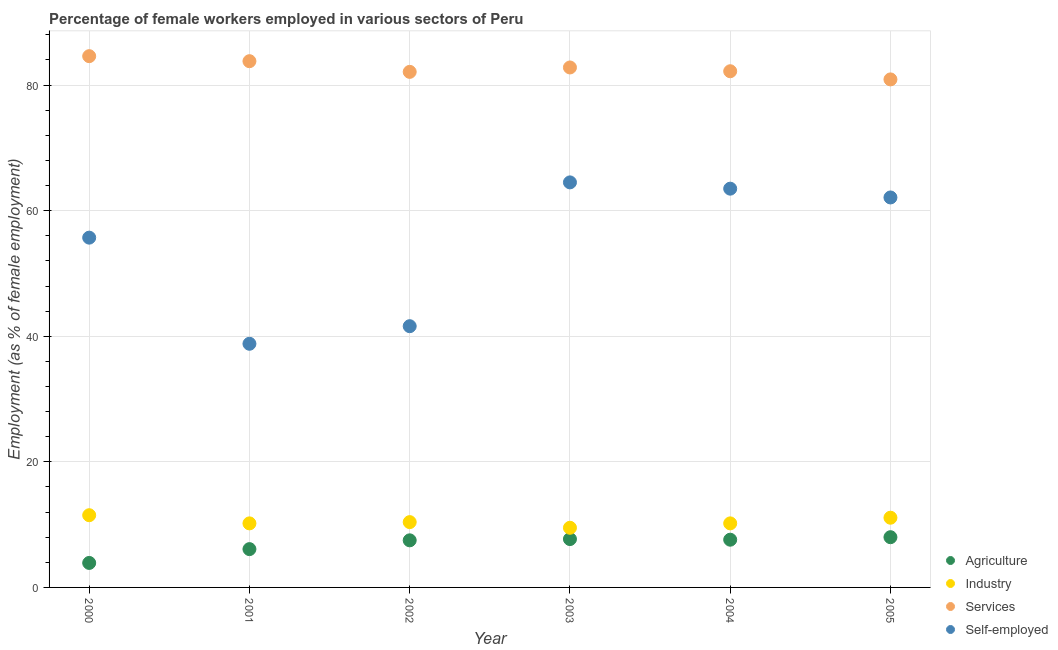What is the percentage of female workers in industry in 2004?
Offer a terse response. 10.2. In which year was the percentage of self employed female workers maximum?
Offer a terse response. 2003. In which year was the percentage of female workers in industry minimum?
Make the answer very short. 2003. What is the total percentage of self employed female workers in the graph?
Provide a succinct answer. 326.2. What is the difference between the percentage of female workers in services in 2003 and that in 2004?
Offer a very short reply. 0.6. What is the difference between the percentage of self employed female workers in 2001 and the percentage of female workers in services in 2004?
Ensure brevity in your answer.  -43.4. What is the average percentage of female workers in agriculture per year?
Ensure brevity in your answer.  6.8. In the year 2004, what is the difference between the percentage of female workers in industry and percentage of female workers in agriculture?
Make the answer very short. 2.6. In how many years, is the percentage of female workers in industry greater than 64 %?
Offer a terse response. 0. What is the ratio of the percentage of female workers in agriculture in 2001 to that in 2004?
Your answer should be compact. 0.8. Is the percentage of female workers in agriculture in 2001 less than that in 2005?
Make the answer very short. Yes. Is the difference between the percentage of female workers in services in 2003 and 2004 greater than the difference between the percentage of self employed female workers in 2003 and 2004?
Make the answer very short. No. What is the difference between the highest and the second highest percentage of female workers in industry?
Your answer should be compact. 0.4. What is the difference between the highest and the lowest percentage of female workers in industry?
Make the answer very short. 2. In how many years, is the percentage of female workers in industry greater than the average percentage of female workers in industry taken over all years?
Keep it short and to the point. 2. Is it the case that in every year, the sum of the percentage of female workers in services and percentage of self employed female workers is greater than the sum of percentage of female workers in agriculture and percentage of female workers in industry?
Ensure brevity in your answer.  No. Is it the case that in every year, the sum of the percentage of female workers in agriculture and percentage of female workers in industry is greater than the percentage of female workers in services?
Provide a short and direct response. No. Does the percentage of female workers in services monotonically increase over the years?
Your answer should be very brief. No. What is the difference between two consecutive major ticks on the Y-axis?
Offer a terse response. 20. Does the graph contain any zero values?
Provide a short and direct response. No. Does the graph contain grids?
Your answer should be very brief. Yes. How many legend labels are there?
Your answer should be compact. 4. How are the legend labels stacked?
Provide a short and direct response. Vertical. What is the title of the graph?
Ensure brevity in your answer.  Percentage of female workers employed in various sectors of Peru. Does "Portugal" appear as one of the legend labels in the graph?
Provide a short and direct response. No. What is the label or title of the X-axis?
Offer a terse response. Year. What is the label or title of the Y-axis?
Your answer should be very brief. Employment (as % of female employment). What is the Employment (as % of female employment) of Agriculture in 2000?
Your response must be concise. 3.9. What is the Employment (as % of female employment) in Services in 2000?
Give a very brief answer. 84.6. What is the Employment (as % of female employment) in Self-employed in 2000?
Give a very brief answer. 55.7. What is the Employment (as % of female employment) of Agriculture in 2001?
Give a very brief answer. 6.1. What is the Employment (as % of female employment) of Industry in 2001?
Your response must be concise. 10.2. What is the Employment (as % of female employment) of Services in 2001?
Your response must be concise. 83.8. What is the Employment (as % of female employment) of Self-employed in 2001?
Offer a terse response. 38.8. What is the Employment (as % of female employment) of Agriculture in 2002?
Keep it short and to the point. 7.5. What is the Employment (as % of female employment) in Industry in 2002?
Your answer should be compact. 10.4. What is the Employment (as % of female employment) in Services in 2002?
Make the answer very short. 82.1. What is the Employment (as % of female employment) of Self-employed in 2002?
Provide a succinct answer. 41.6. What is the Employment (as % of female employment) of Agriculture in 2003?
Keep it short and to the point. 7.7. What is the Employment (as % of female employment) in Services in 2003?
Give a very brief answer. 82.8. What is the Employment (as % of female employment) of Self-employed in 2003?
Make the answer very short. 64.5. What is the Employment (as % of female employment) in Agriculture in 2004?
Give a very brief answer. 7.6. What is the Employment (as % of female employment) in Industry in 2004?
Provide a short and direct response. 10.2. What is the Employment (as % of female employment) of Services in 2004?
Keep it short and to the point. 82.2. What is the Employment (as % of female employment) of Self-employed in 2004?
Ensure brevity in your answer.  63.5. What is the Employment (as % of female employment) of Agriculture in 2005?
Offer a very short reply. 8. What is the Employment (as % of female employment) in Industry in 2005?
Ensure brevity in your answer.  11.1. What is the Employment (as % of female employment) in Services in 2005?
Keep it short and to the point. 80.9. What is the Employment (as % of female employment) of Self-employed in 2005?
Provide a short and direct response. 62.1. Across all years, what is the maximum Employment (as % of female employment) in Agriculture?
Provide a succinct answer. 8. Across all years, what is the maximum Employment (as % of female employment) of Services?
Give a very brief answer. 84.6. Across all years, what is the maximum Employment (as % of female employment) of Self-employed?
Make the answer very short. 64.5. Across all years, what is the minimum Employment (as % of female employment) of Agriculture?
Offer a very short reply. 3.9. Across all years, what is the minimum Employment (as % of female employment) of Services?
Keep it short and to the point. 80.9. Across all years, what is the minimum Employment (as % of female employment) of Self-employed?
Keep it short and to the point. 38.8. What is the total Employment (as % of female employment) of Agriculture in the graph?
Give a very brief answer. 40.8. What is the total Employment (as % of female employment) of Industry in the graph?
Offer a very short reply. 62.9. What is the total Employment (as % of female employment) of Services in the graph?
Provide a short and direct response. 496.4. What is the total Employment (as % of female employment) in Self-employed in the graph?
Offer a very short reply. 326.2. What is the difference between the Employment (as % of female employment) in Agriculture in 2000 and that in 2001?
Your response must be concise. -2.2. What is the difference between the Employment (as % of female employment) in Industry in 2000 and that in 2001?
Keep it short and to the point. 1.3. What is the difference between the Employment (as % of female employment) of Services in 2000 and that in 2001?
Keep it short and to the point. 0.8. What is the difference between the Employment (as % of female employment) in Industry in 2000 and that in 2002?
Make the answer very short. 1.1. What is the difference between the Employment (as % of female employment) of Self-employed in 2000 and that in 2003?
Make the answer very short. -8.8. What is the difference between the Employment (as % of female employment) of Industry in 2000 and that in 2004?
Give a very brief answer. 1.3. What is the difference between the Employment (as % of female employment) in Agriculture in 2000 and that in 2005?
Make the answer very short. -4.1. What is the difference between the Employment (as % of female employment) of Industry in 2000 and that in 2005?
Make the answer very short. 0.4. What is the difference between the Employment (as % of female employment) of Services in 2000 and that in 2005?
Your response must be concise. 3.7. What is the difference between the Employment (as % of female employment) of Self-employed in 2000 and that in 2005?
Offer a terse response. -6.4. What is the difference between the Employment (as % of female employment) in Agriculture in 2001 and that in 2002?
Make the answer very short. -1.4. What is the difference between the Employment (as % of female employment) of Self-employed in 2001 and that in 2003?
Provide a short and direct response. -25.7. What is the difference between the Employment (as % of female employment) in Industry in 2001 and that in 2004?
Make the answer very short. 0. What is the difference between the Employment (as % of female employment) of Self-employed in 2001 and that in 2004?
Offer a terse response. -24.7. What is the difference between the Employment (as % of female employment) of Self-employed in 2001 and that in 2005?
Give a very brief answer. -23.3. What is the difference between the Employment (as % of female employment) of Industry in 2002 and that in 2003?
Offer a very short reply. 0.9. What is the difference between the Employment (as % of female employment) in Services in 2002 and that in 2003?
Ensure brevity in your answer.  -0.7. What is the difference between the Employment (as % of female employment) of Self-employed in 2002 and that in 2003?
Your answer should be very brief. -22.9. What is the difference between the Employment (as % of female employment) in Agriculture in 2002 and that in 2004?
Your response must be concise. -0.1. What is the difference between the Employment (as % of female employment) of Services in 2002 and that in 2004?
Provide a succinct answer. -0.1. What is the difference between the Employment (as % of female employment) in Self-employed in 2002 and that in 2004?
Offer a very short reply. -21.9. What is the difference between the Employment (as % of female employment) in Self-employed in 2002 and that in 2005?
Make the answer very short. -20.5. What is the difference between the Employment (as % of female employment) of Industry in 2003 and that in 2004?
Keep it short and to the point. -0.7. What is the difference between the Employment (as % of female employment) in Services in 2003 and that in 2004?
Provide a short and direct response. 0.6. What is the difference between the Employment (as % of female employment) in Agriculture in 2003 and that in 2005?
Your response must be concise. -0.3. What is the difference between the Employment (as % of female employment) in Industry in 2003 and that in 2005?
Offer a very short reply. -1.6. What is the difference between the Employment (as % of female employment) in Self-employed in 2003 and that in 2005?
Keep it short and to the point. 2.4. What is the difference between the Employment (as % of female employment) in Industry in 2004 and that in 2005?
Make the answer very short. -0.9. What is the difference between the Employment (as % of female employment) in Services in 2004 and that in 2005?
Provide a short and direct response. 1.3. What is the difference between the Employment (as % of female employment) in Self-employed in 2004 and that in 2005?
Provide a succinct answer. 1.4. What is the difference between the Employment (as % of female employment) in Agriculture in 2000 and the Employment (as % of female employment) in Industry in 2001?
Keep it short and to the point. -6.3. What is the difference between the Employment (as % of female employment) in Agriculture in 2000 and the Employment (as % of female employment) in Services in 2001?
Offer a terse response. -79.9. What is the difference between the Employment (as % of female employment) of Agriculture in 2000 and the Employment (as % of female employment) of Self-employed in 2001?
Your response must be concise. -34.9. What is the difference between the Employment (as % of female employment) of Industry in 2000 and the Employment (as % of female employment) of Services in 2001?
Your answer should be compact. -72.3. What is the difference between the Employment (as % of female employment) of Industry in 2000 and the Employment (as % of female employment) of Self-employed in 2001?
Provide a short and direct response. -27.3. What is the difference between the Employment (as % of female employment) of Services in 2000 and the Employment (as % of female employment) of Self-employed in 2001?
Make the answer very short. 45.8. What is the difference between the Employment (as % of female employment) of Agriculture in 2000 and the Employment (as % of female employment) of Services in 2002?
Give a very brief answer. -78.2. What is the difference between the Employment (as % of female employment) of Agriculture in 2000 and the Employment (as % of female employment) of Self-employed in 2002?
Your response must be concise. -37.7. What is the difference between the Employment (as % of female employment) of Industry in 2000 and the Employment (as % of female employment) of Services in 2002?
Your answer should be very brief. -70.6. What is the difference between the Employment (as % of female employment) of Industry in 2000 and the Employment (as % of female employment) of Self-employed in 2002?
Your answer should be very brief. -30.1. What is the difference between the Employment (as % of female employment) in Services in 2000 and the Employment (as % of female employment) in Self-employed in 2002?
Offer a very short reply. 43. What is the difference between the Employment (as % of female employment) of Agriculture in 2000 and the Employment (as % of female employment) of Industry in 2003?
Offer a terse response. -5.6. What is the difference between the Employment (as % of female employment) of Agriculture in 2000 and the Employment (as % of female employment) of Services in 2003?
Your answer should be very brief. -78.9. What is the difference between the Employment (as % of female employment) in Agriculture in 2000 and the Employment (as % of female employment) in Self-employed in 2003?
Provide a succinct answer. -60.6. What is the difference between the Employment (as % of female employment) in Industry in 2000 and the Employment (as % of female employment) in Services in 2003?
Make the answer very short. -71.3. What is the difference between the Employment (as % of female employment) of Industry in 2000 and the Employment (as % of female employment) of Self-employed in 2003?
Your answer should be very brief. -53. What is the difference between the Employment (as % of female employment) of Services in 2000 and the Employment (as % of female employment) of Self-employed in 2003?
Provide a succinct answer. 20.1. What is the difference between the Employment (as % of female employment) in Agriculture in 2000 and the Employment (as % of female employment) in Industry in 2004?
Keep it short and to the point. -6.3. What is the difference between the Employment (as % of female employment) of Agriculture in 2000 and the Employment (as % of female employment) of Services in 2004?
Give a very brief answer. -78.3. What is the difference between the Employment (as % of female employment) in Agriculture in 2000 and the Employment (as % of female employment) in Self-employed in 2004?
Offer a terse response. -59.6. What is the difference between the Employment (as % of female employment) in Industry in 2000 and the Employment (as % of female employment) in Services in 2004?
Your response must be concise. -70.7. What is the difference between the Employment (as % of female employment) of Industry in 2000 and the Employment (as % of female employment) of Self-employed in 2004?
Your answer should be very brief. -52. What is the difference between the Employment (as % of female employment) in Services in 2000 and the Employment (as % of female employment) in Self-employed in 2004?
Offer a terse response. 21.1. What is the difference between the Employment (as % of female employment) of Agriculture in 2000 and the Employment (as % of female employment) of Industry in 2005?
Ensure brevity in your answer.  -7.2. What is the difference between the Employment (as % of female employment) of Agriculture in 2000 and the Employment (as % of female employment) of Services in 2005?
Make the answer very short. -77. What is the difference between the Employment (as % of female employment) in Agriculture in 2000 and the Employment (as % of female employment) in Self-employed in 2005?
Give a very brief answer. -58.2. What is the difference between the Employment (as % of female employment) in Industry in 2000 and the Employment (as % of female employment) in Services in 2005?
Your answer should be very brief. -69.4. What is the difference between the Employment (as % of female employment) in Industry in 2000 and the Employment (as % of female employment) in Self-employed in 2005?
Provide a short and direct response. -50.6. What is the difference between the Employment (as % of female employment) in Agriculture in 2001 and the Employment (as % of female employment) in Services in 2002?
Offer a very short reply. -76. What is the difference between the Employment (as % of female employment) in Agriculture in 2001 and the Employment (as % of female employment) in Self-employed in 2002?
Keep it short and to the point. -35.5. What is the difference between the Employment (as % of female employment) of Industry in 2001 and the Employment (as % of female employment) of Services in 2002?
Provide a short and direct response. -71.9. What is the difference between the Employment (as % of female employment) of Industry in 2001 and the Employment (as % of female employment) of Self-employed in 2002?
Your answer should be very brief. -31.4. What is the difference between the Employment (as % of female employment) of Services in 2001 and the Employment (as % of female employment) of Self-employed in 2002?
Provide a short and direct response. 42.2. What is the difference between the Employment (as % of female employment) of Agriculture in 2001 and the Employment (as % of female employment) of Industry in 2003?
Keep it short and to the point. -3.4. What is the difference between the Employment (as % of female employment) in Agriculture in 2001 and the Employment (as % of female employment) in Services in 2003?
Your answer should be compact. -76.7. What is the difference between the Employment (as % of female employment) of Agriculture in 2001 and the Employment (as % of female employment) of Self-employed in 2003?
Provide a short and direct response. -58.4. What is the difference between the Employment (as % of female employment) of Industry in 2001 and the Employment (as % of female employment) of Services in 2003?
Provide a succinct answer. -72.6. What is the difference between the Employment (as % of female employment) in Industry in 2001 and the Employment (as % of female employment) in Self-employed in 2003?
Your answer should be very brief. -54.3. What is the difference between the Employment (as % of female employment) of Services in 2001 and the Employment (as % of female employment) of Self-employed in 2003?
Provide a succinct answer. 19.3. What is the difference between the Employment (as % of female employment) of Agriculture in 2001 and the Employment (as % of female employment) of Services in 2004?
Give a very brief answer. -76.1. What is the difference between the Employment (as % of female employment) in Agriculture in 2001 and the Employment (as % of female employment) in Self-employed in 2004?
Give a very brief answer. -57.4. What is the difference between the Employment (as % of female employment) in Industry in 2001 and the Employment (as % of female employment) in Services in 2004?
Keep it short and to the point. -72. What is the difference between the Employment (as % of female employment) of Industry in 2001 and the Employment (as % of female employment) of Self-employed in 2004?
Your response must be concise. -53.3. What is the difference between the Employment (as % of female employment) of Services in 2001 and the Employment (as % of female employment) of Self-employed in 2004?
Give a very brief answer. 20.3. What is the difference between the Employment (as % of female employment) of Agriculture in 2001 and the Employment (as % of female employment) of Industry in 2005?
Provide a succinct answer. -5. What is the difference between the Employment (as % of female employment) of Agriculture in 2001 and the Employment (as % of female employment) of Services in 2005?
Your answer should be very brief. -74.8. What is the difference between the Employment (as % of female employment) in Agriculture in 2001 and the Employment (as % of female employment) in Self-employed in 2005?
Give a very brief answer. -56. What is the difference between the Employment (as % of female employment) of Industry in 2001 and the Employment (as % of female employment) of Services in 2005?
Provide a short and direct response. -70.7. What is the difference between the Employment (as % of female employment) of Industry in 2001 and the Employment (as % of female employment) of Self-employed in 2005?
Give a very brief answer. -51.9. What is the difference between the Employment (as % of female employment) in Services in 2001 and the Employment (as % of female employment) in Self-employed in 2005?
Make the answer very short. 21.7. What is the difference between the Employment (as % of female employment) of Agriculture in 2002 and the Employment (as % of female employment) of Industry in 2003?
Keep it short and to the point. -2. What is the difference between the Employment (as % of female employment) in Agriculture in 2002 and the Employment (as % of female employment) in Services in 2003?
Your response must be concise. -75.3. What is the difference between the Employment (as % of female employment) of Agriculture in 2002 and the Employment (as % of female employment) of Self-employed in 2003?
Offer a very short reply. -57. What is the difference between the Employment (as % of female employment) in Industry in 2002 and the Employment (as % of female employment) in Services in 2003?
Provide a short and direct response. -72.4. What is the difference between the Employment (as % of female employment) in Industry in 2002 and the Employment (as % of female employment) in Self-employed in 2003?
Keep it short and to the point. -54.1. What is the difference between the Employment (as % of female employment) in Services in 2002 and the Employment (as % of female employment) in Self-employed in 2003?
Keep it short and to the point. 17.6. What is the difference between the Employment (as % of female employment) in Agriculture in 2002 and the Employment (as % of female employment) in Industry in 2004?
Give a very brief answer. -2.7. What is the difference between the Employment (as % of female employment) of Agriculture in 2002 and the Employment (as % of female employment) of Services in 2004?
Provide a succinct answer. -74.7. What is the difference between the Employment (as % of female employment) of Agriculture in 2002 and the Employment (as % of female employment) of Self-employed in 2004?
Make the answer very short. -56. What is the difference between the Employment (as % of female employment) in Industry in 2002 and the Employment (as % of female employment) in Services in 2004?
Your response must be concise. -71.8. What is the difference between the Employment (as % of female employment) of Industry in 2002 and the Employment (as % of female employment) of Self-employed in 2004?
Provide a succinct answer. -53.1. What is the difference between the Employment (as % of female employment) in Services in 2002 and the Employment (as % of female employment) in Self-employed in 2004?
Make the answer very short. 18.6. What is the difference between the Employment (as % of female employment) in Agriculture in 2002 and the Employment (as % of female employment) in Industry in 2005?
Keep it short and to the point. -3.6. What is the difference between the Employment (as % of female employment) in Agriculture in 2002 and the Employment (as % of female employment) in Services in 2005?
Offer a terse response. -73.4. What is the difference between the Employment (as % of female employment) in Agriculture in 2002 and the Employment (as % of female employment) in Self-employed in 2005?
Make the answer very short. -54.6. What is the difference between the Employment (as % of female employment) in Industry in 2002 and the Employment (as % of female employment) in Services in 2005?
Offer a very short reply. -70.5. What is the difference between the Employment (as % of female employment) of Industry in 2002 and the Employment (as % of female employment) of Self-employed in 2005?
Give a very brief answer. -51.7. What is the difference between the Employment (as % of female employment) in Agriculture in 2003 and the Employment (as % of female employment) in Industry in 2004?
Your answer should be very brief. -2.5. What is the difference between the Employment (as % of female employment) of Agriculture in 2003 and the Employment (as % of female employment) of Services in 2004?
Provide a succinct answer. -74.5. What is the difference between the Employment (as % of female employment) of Agriculture in 2003 and the Employment (as % of female employment) of Self-employed in 2004?
Your answer should be very brief. -55.8. What is the difference between the Employment (as % of female employment) in Industry in 2003 and the Employment (as % of female employment) in Services in 2004?
Offer a terse response. -72.7. What is the difference between the Employment (as % of female employment) of Industry in 2003 and the Employment (as % of female employment) of Self-employed in 2004?
Your answer should be very brief. -54. What is the difference between the Employment (as % of female employment) of Services in 2003 and the Employment (as % of female employment) of Self-employed in 2004?
Provide a short and direct response. 19.3. What is the difference between the Employment (as % of female employment) in Agriculture in 2003 and the Employment (as % of female employment) in Services in 2005?
Offer a terse response. -73.2. What is the difference between the Employment (as % of female employment) of Agriculture in 2003 and the Employment (as % of female employment) of Self-employed in 2005?
Offer a terse response. -54.4. What is the difference between the Employment (as % of female employment) in Industry in 2003 and the Employment (as % of female employment) in Services in 2005?
Provide a short and direct response. -71.4. What is the difference between the Employment (as % of female employment) of Industry in 2003 and the Employment (as % of female employment) of Self-employed in 2005?
Your response must be concise. -52.6. What is the difference between the Employment (as % of female employment) in Services in 2003 and the Employment (as % of female employment) in Self-employed in 2005?
Provide a succinct answer. 20.7. What is the difference between the Employment (as % of female employment) in Agriculture in 2004 and the Employment (as % of female employment) in Industry in 2005?
Your answer should be compact. -3.5. What is the difference between the Employment (as % of female employment) of Agriculture in 2004 and the Employment (as % of female employment) of Services in 2005?
Your answer should be compact. -73.3. What is the difference between the Employment (as % of female employment) of Agriculture in 2004 and the Employment (as % of female employment) of Self-employed in 2005?
Provide a short and direct response. -54.5. What is the difference between the Employment (as % of female employment) in Industry in 2004 and the Employment (as % of female employment) in Services in 2005?
Ensure brevity in your answer.  -70.7. What is the difference between the Employment (as % of female employment) of Industry in 2004 and the Employment (as % of female employment) of Self-employed in 2005?
Provide a short and direct response. -51.9. What is the difference between the Employment (as % of female employment) in Services in 2004 and the Employment (as % of female employment) in Self-employed in 2005?
Offer a very short reply. 20.1. What is the average Employment (as % of female employment) of Industry per year?
Your answer should be compact. 10.48. What is the average Employment (as % of female employment) in Services per year?
Give a very brief answer. 82.73. What is the average Employment (as % of female employment) in Self-employed per year?
Ensure brevity in your answer.  54.37. In the year 2000, what is the difference between the Employment (as % of female employment) in Agriculture and Employment (as % of female employment) in Services?
Offer a terse response. -80.7. In the year 2000, what is the difference between the Employment (as % of female employment) of Agriculture and Employment (as % of female employment) of Self-employed?
Give a very brief answer. -51.8. In the year 2000, what is the difference between the Employment (as % of female employment) in Industry and Employment (as % of female employment) in Services?
Keep it short and to the point. -73.1. In the year 2000, what is the difference between the Employment (as % of female employment) of Industry and Employment (as % of female employment) of Self-employed?
Your answer should be very brief. -44.2. In the year 2000, what is the difference between the Employment (as % of female employment) in Services and Employment (as % of female employment) in Self-employed?
Offer a terse response. 28.9. In the year 2001, what is the difference between the Employment (as % of female employment) in Agriculture and Employment (as % of female employment) in Services?
Your answer should be very brief. -77.7. In the year 2001, what is the difference between the Employment (as % of female employment) of Agriculture and Employment (as % of female employment) of Self-employed?
Your answer should be very brief. -32.7. In the year 2001, what is the difference between the Employment (as % of female employment) of Industry and Employment (as % of female employment) of Services?
Your response must be concise. -73.6. In the year 2001, what is the difference between the Employment (as % of female employment) of Industry and Employment (as % of female employment) of Self-employed?
Keep it short and to the point. -28.6. In the year 2002, what is the difference between the Employment (as % of female employment) of Agriculture and Employment (as % of female employment) of Services?
Your answer should be very brief. -74.6. In the year 2002, what is the difference between the Employment (as % of female employment) in Agriculture and Employment (as % of female employment) in Self-employed?
Offer a terse response. -34.1. In the year 2002, what is the difference between the Employment (as % of female employment) in Industry and Employment (as % of female employment) in Services?
Give a very brief answer. -71.7. In the year 2002, what is the difference between the Employment (as % of female employment) in Industry and Employment (as % of female employment) in Self-employed?
Keep it short and to the point. -31.2. In the year 2002, what is the difference between the Employment (as % of female employment) of Services and Employment (as % of female employment) of Self-employed?
Provide a short and direct response. 40.5. In the year 2003, what is the difference between the Employment (as % of female employment) in Agriculture and Employment (as % of female employment) in Services?
Provide a succinct answer. -75.1. In the year 2003, what is the difference between the Employment (as % of female employment) of Agriculture and Employment (as % of female employment) of Self-employed?
Offer a very short reply. -56.8. In the year 2003, what is the difference between the Employment (as % of female employment) of Industry and Employment (as % of female employment) of Services?
Your answer should be compact. -73.3. In the year 2003, what is the difference between the Employment (as % of female employment) of Industry and Employment (as % of female employment) of Self-employed?
Give a very brief answer. -55. In the year 2003, what is the difference between the Employment (as % of female employment) of Services and Employment (as % of female employment) of Self-employed?
Offer a terse response. 18.3. In the year 2004, what is the difference between the Employment (as % of female employment) of Agriculture and Employment (as % of female employment) of Industry?
Offer a very short reply. -2.6. In the year 2004, what is the difference between the Employment (as % of female employment) in Agriculture and Employment (as % of female employment) in Services?
Offer a very short reply. -74.6. In the year 2004, what is the difference between the Employment (as % of female employment) of Agriculture and Employment (as % of female employment) of Self-employed?
Your response must be concise. -55.9. In the year 2004, what is the difference between the Employment (as % of female employment) in Industry and Employment (as % of female employment) in Services?
Give a very brief answer. -72. In the year 2004, what is the difference between the Employment (as % of female employment) of Industry and Employment (as % of female employment) of Self-employed?
Your answer should be very brief. -53.3. In the year 2005, what is the difference between the Employment (as % of female employment) of Agriculture and Employment (as % of female employment) of Services?
Keep it short and to the point. -72.9. In the year 2005, what is the difference between the Employment (as % of female employment) of Agriculture and Employment (as % of female employment) of Self-employed?
Provide a succinct answer. -54.1. In the year 2005, what is the difference between the Employment (as % of female employment) in Industry and Employment (as % of female employment) in Services?
Provide a short and direct response. -69.8. In the year 2005, what is the difference between the Employment (as % of female employment) of Industry and Employment (as % of female employment) of Self-employed?
Ensure brevity in your answer.  -51. What is the ratio of the Employment (as % of female employment) of Agriculture in 2000 to that in 2001?
Your answer should be compact. 0.64. What is the ratio of the Employment (as % of female employment) of Industry in 2000 to that in 2001?
Offer a very short reply. 1.13. What is the ratio of the Employment (as % of female employment) of Services in 2000 to that in 2001?
Offer a very short reply. 1.01. What is the ratio of the Employment (as % of female employment) of Self-employed in 2000 to that in 2001?
Your response must be concise. 1.44. What is the ratio of the Employment (as % of female employment) in Agriculture in 2000 to that in 2002?
Give a very brief answer. 0.52. What is the ratio of the Employment (as % of female employment) of Industry in 2000 to that in 2002?
Give a very brief answer. 1.11. What is the ratio of the Employment (as % of female employment) of Services in 2000 to that in 2002?
Ensure brevity in your answer.  1.03. What is the ratio of the Employment (as % of female employment) in Self-employed in 2000 to that in 2002?
Your answer should be very brief. 1.34. What is the ratio of the Employment (as % of female employment) in Agriculture in 2000 to that in 2003?
Keep it short and to the point. 0.51. What is the ratio of the Employment (as % of female employment) in Industry in 2000 to that in 2003?
Give a very brief answer. 1.21. What is the ratio of the Employment (as % of female employment) in Services in 2000 to that in 2003?
Make the answer very short. 1.02. What is the ratio of the Employment (as % of female employment) of Self-employed in 2000 to that in 2003?
Give a very brief answer. 0.86. What is the ratio of the Employment (as % of female employment) of Agriculture in 2000 to that in 2004?
Keep it short and to the point. 0.51. What is the ratio of the Employment (as % of female employment) of Industry in 2000 to that in 2004?
Provide a succinct answer. 1.13. What is the ratio of the Employment (as % of female employment) in Services in 2000 to that in 2004?
Make the answer very short. 1.03. What is the ratio of the Employment (as % of female employment) of Self-employed in 2000 to that in 2004?
Your answer should be compact. 0.88. What is the ratio of the Employment (as % of female employment) in Agriculture in 2000 to that in 2005?
Your response must be concise. 0.49. What is the ratio of the Employment (as % of female employment) in Industry in 2000 to that in 2005?
Provide a succinct answer. 1.04. What is the ratio of the Employment (as % of female employment) in Services in 2000 to that in 2005?
Make the answer very short. 1.05. What is the ratio of the Employment (as % of female employment) in Self-employed in 2000 to that in 2005?
Ensure brevity in your answer.  0.9. What is the ratio of the Employment (as % of female employment) in Agriculture in 2001 to that in 2002?
Give a very brief answer. 0.81. What is the ratio of the Employment (as % of female employment) in Industry in 2001 to that in 2002?
Give a very brief answer. 0.98. What is the ratio of the Employment (as % of female employment) in Services in 2001 to that in 2002?
Make the answer very short. 1.02. What is the ratio of the Employment (as % of female employment) of Self-employed in 2001 to that in 2002?
Your response must be concise. 0.93. What is the ratio of the Employment (as % of female employment) in Agriculture in 2001 to that in 2003?
Ensure brevity in your answer.  0.79. What is the ratio of the Employment (as % of female employment) of Industry in 2001 to that in 2003?
Offer a terse response. 1.07. What is the ratio of the Employment (as % of female employment) in Services in 2001 to that in 2003?
Make the answer very short. 1.01. What is the ratio of the Employment (as % of female employment) in Self-employed in 2001 to that in 2003?
Ensure brevity in your answer.  0.6. What is the ratio of the Employment (as % of female employment) in Agriculture in 2001 to that in 2004?
Your answer should be very brief. 0.8. What is the ratio of the Employment (as % of female employment) of Industry in 2001 to that in 2004?
Provide a short and direct response. 1. What is the ratio of the Employment (as % of female employment) of Services in 2001 to that in 2004?
Keep it short and to the point. 1.02. What is the ratio of the Employment (as % of female employment) in Self-employed in 2001 to that in 2004?
Provide a short and direct response. 0.61. What is the ratio of the Employment (as % of female employment) of Agriculture in 2001 to that in 2005?
Offer a very short reply. 0.76. What is the ratio of the Employment (as % of female employment) of Industry in 2001 to that in 2005?
Offer a very short reply. 0.92. What is the ratio of the Employment (as % of female employment) in Services in 2001 to that in 2005?
Keep it short and to the point. 1.04. What is the ratio of the Employment (as % of female employment) of Self-employed in 2001 to that in 2005?
Ensure brevity in your answer.  0.62. What is the ratio of the Employment (as % of female employment) of Industry in 2002 to that in 2003?
Ensure brevity in your answer.  1.09. What is the ratio of the Employment (as % of female employment) of Self-employed in 2002 to that in 2003?
Give a very brief answer. 0.65. What is the ratio of the Employment (as % of female employment) of Industry in 2002 to that in 2004?
Provide a short and direct response. 1.02. What is the ratio of the Employment (as % of female employment) of Services in 2002 to that in 2004?
Ensure brevity in your answer.  1. What is the ratio of the Employment (as % of female employment) of Self-employed in 2002 to that in 2004?
Your answer should be compact. 0.66. What is the ratio of the Employment (as % of female employment) in Agriculture in 2002 to that in 2005?
Offer a terse response. 0.94. What is the ratio of the Employment (as % of female employment) in Industry in 2002 to that in 2005?
Provide a short and direct response. 0.94. What is the ratio of the Employment (as % of female employment) of Services in 2002 to that in 2005?
Offer a very short reply. 1.01. What is the ratio of the Employment (as % of female employment) in Self-employed in 2002 to that in 2005?
Give a very brief answer. 0.67. What is the ratio of the Employment (as % of female employment) in Agriculture in 2003 to that in 2004?
Your answer should be compact. 1.01. What is the ratio of the Employment (as % of female employment) in Industry in 2003 to that in 2004?
Keep it short and to the point. 0.93. What is the ratio of the Employment (as % of female employment) in Services in 2003 to that in 2004?
Your response must be concise. 1.01. What is the ratio of the Employment (as % of female employment) in Self-employed in 2003 to that in 2004?
Your answer should be compact. 1.02. What is the ratio of the Employment (as % of female employment) of Agriculture in 2003 to that in 2005?
Keep it short and to the point. 0.96. What is the ratio of the Employment (as % of female employment) in Industry in 2003 to that in 2005?
Make the answer very short. 0.86. What is the ratio of the Employment (as % of female employment) of Services in 2003 to that in 2005?
Provide a succinct answer. 1.02. What is the ratio of the Employment (as % of female employment) of Self-employed in 2003 to that in 2005?
Make the answer very short. 1.04. What is the ratio of the Employment (as % of female employment) of Industry in 2004 to that in 2005?
Offer a very short reply. 0.92. What is the ratio of the Employment (as % of female employment) of Services in 2004 to that in 2005?
Keep it short and to the point. 1.02. What is the ratio of the Employment (as % of female employment) in Self-employed in 2004 to that in 2005?
Provide a short and direct response. 1.02. What is the difference between the highest and the second highest Employment (as % of female employment) of Agriculture?
Your answer should be compact. 0.3. What is the difference between the highest and the second highest Employment (as % of female employment) of Industry?
Provide a succinct answer. 0.4. What is the difference between the highest and the second highest Employment (as % of female employment) of Self-employed?
Offer a very short reply. 1. What is the difference between the highest and the lowest Employment (as % of female employment) in Self-employed?
Provide a succinct answer. 25.7. 